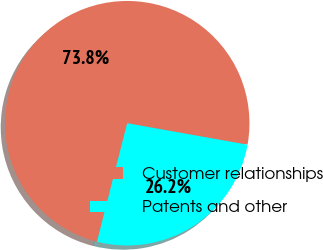Convert chart. <chart><loc_0><loc_0><loc_500><loc_500><pie_chart><fcel>Customer relationships<fcel>Patents and other<nl><fcel>73.84%<fcel>26.16%<nl></chart> 